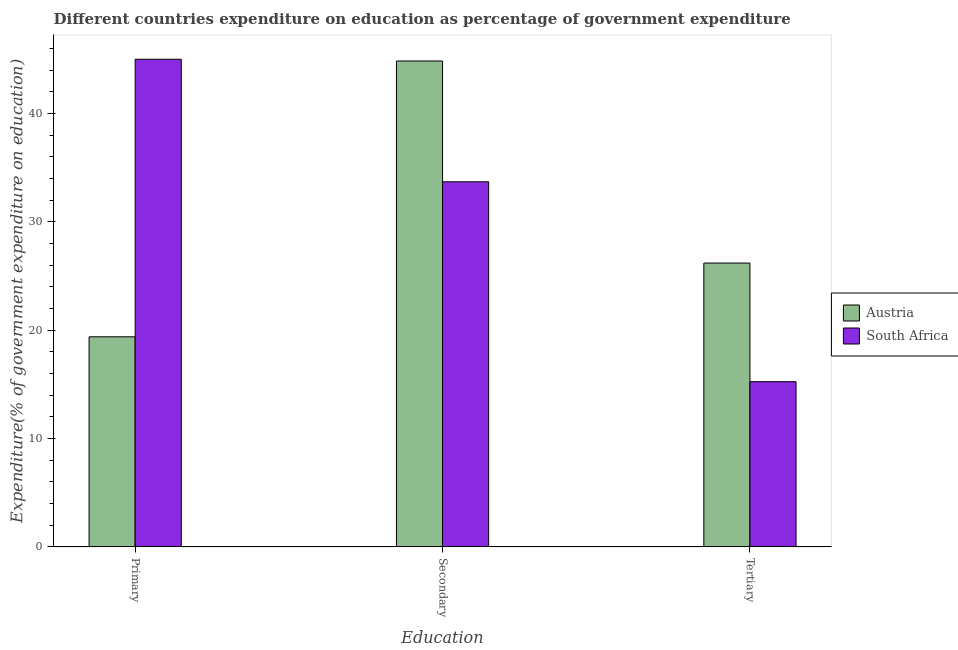How many different coloured bars are there?
Offer a very short reply. 2. How many bars are there on the 3rd tick from the right?
Your answer should be compact. 2. What is the label of the 3rd group of bars from the left?
Your response must be concise. Tertiary. What is the expenditure on primary education in Austria?
Your answer should be compact. 19.38. Across all countries, what is the maximum expenditure on primary education?
Your answer should be very brief. 44.99. Across all countries, what is the minimum expenditure on secondary education?
Make the answer very short. 33.69. In which country was the expenditure on primary education maximum?
Offer a very short reply. South Africa. In which country was the expenditure on primary education minimum?
Make the answer very short. Austria. What is the total expenditure on secondary education in the graph?
Give a very brief answer. 78.52. What is the difference between the expenditure on tertiary education in South Africa and that in Austria?
Provide a succinct answer. -10.94. What is the difference between the expenditure on tertiary education in South Africa and the expenditure on primary education in Austria?
Ensure brevity in your answer.  -4.14. What is the average expenditure on secondary education per country?
Provide a succinct answer. 39.26. What is the difference between the expenditure on tertiary education and expenditure on primary education in South Africa?
Offer a very short reply. -29.75. In how many countries, is the expenditure on primary education greater than 22 %?
Keep it short and to the point. 1. What is the ratio of the expenditure on secondary education in South Africa to that in Austria?
Your answer should be compact. 0.75. What is the difference between the highest and the second highest expenditure on tertiary education?
Provide a short and direct response. 10.94. What is the difference between the highest and the lowest expenditure on secondary education?
Keep it short and to the point. 11.15. In how many countries, is the expenditure on secondary education greater than the average expenditure on secondary education taken over all countries?
Offer a terse response. 1. What does the 2nd bar from the left in Secondary represents?
Offer a terse response. South Africa. What does the 1st bar from the right in Primary represents?
Provide a short and direct response. South Africa. How many bars are there?
Your answer should be compact. 6. Are all the bars in the graph horizontal?
Provide a short and direct response. No. How many countries are there in the graph?
Offer a terse response. 2. Are the values on the major ticks of Y-axis written in scientific E-notation?
Offer a terse response. No. Does the graph contain any zero values?
Keep it short and to the point. No. Does the graph contain grids?
Your answer should be very brief. No. Where does the legend appear in the graph?
Offer a terse response. Center right. How are the legend labels stacked?
Offer a terse response. Vertical. What is the title of the graph?
Your answer should be very brief. Different countries expenditure on education as percentage of government expenditure. What is the label or title of the X-axis?
Offer a terse response. Education. What is the label or title of the Y-axis?
Make the answer very short. Expenditure(% of government expenditure on education). What is the Expenditure(% of government expenditure on education) of Austria in Primary?
Provide a succinct answer. 19.38. What is the Expenditure(% of government expenditure on education) of South Africa in Primary?
Give a very brief answer. 44.99. What is the Expenditure(% of government expenditure on education) in Austria in Secondary?
Offer a very short reply. 44.83. What is the Expenditure(% of government expenditure on education) in South Africa in Secondary?
Provide a succinct answer. 33.69. What is the Expenditure(% of government expenditure on education) of Austria in Tertiary?
Offer a very short reply. 26.19. What is the Expenditure(% of government expenditure on education) of South Africa in Tertiary?
Your answer should be compact. 15.24. Across all Education, what is the maximum Expenditure(% of government expenditure on education) of Austria?
Offer a very short reply. 44.83. Across all Education, what is the maximum Expenditure(% of government expenditure on education) in South Africa?
Your answer should be very brief. 44.99. Across all Education, what is the minimum Expenditure(% of government expenditure on education) in Austria?
Make the answer very short. 19.38. Across all Education, what is the minimum Expenditure(% of government expenditure on education) in South Africa?
Ensure brevity in your answer.  15.24. What is the total Expenditure(% of government expenditure on education) of Austria in the graph?
Keep it short and to the point. 90.4. What is the total Expenditure(% of government expenditure on education) of South Africa in the graph?
Make the answer very short. 93.92. What is the difference between the Expenditure(% of government expenditure on education) of Austria in Primary and that in Secondary?
Offer a terse response. -25.45. What is the difference between the Expenditure(% of government expenditure on education) in South Africa in Primary and that in Secondary?
Make the answer very short. 11.31. What is the difference between the Expenditure(% of government expenditure on education) of Austria in Primary and that in Tertiary?
Make the answer very short. -6.8. What is the difference between the Expenditure(% of government expenditure on education) in South Africa in Primary and that in Tertiary?
Give a very brief answer. 29.75. What is the difference between the Expenditure(% of government expenditure on education) of Austria in Secondary and that in Tertiary?
Your answer should be compact. 18.65. What is the difference between the Expenditure(% of government expenditure on education) in South Africa in Secondary and that in Tertiary?
Provide a succinct answer. 18.44. What is the difference between the Expenditure(% of government expenditure on education) of Austria in Primary and the Expenditure(% of government expenditure on education) of South Africa in Secondary?
Offer a terse response. -14.3. What is the difference between the Expenditure(% of government expenditure on education) of Austria in Primary and the Expenditure(% of government expenditure on education) of South Africa in Tertiary?
Make the answer very short. 4.14. What is the difference between the Expenditure(% of government expenditure on education) of Austria in Secondary and the Expenditure(% of government expenditure on education) of South Africa in Tertiary?
Offer a very short reply. 29.59. What is the average Expenditure(% of government expenditure on education) in Austria per Education?
Give a very brief answer. 30.13. What is the average Expenditure(% of government expenditure on education) of South Africa per Education?
Your answer should be very brief. 31.31. What is the difference between the Expenditure(% of government expenditure on education) in Austria and Expenditure(% of government expenditure on education) in South Africa in Primary?
Offer a very short reply. -25.61. What is the difference between the Expenditure(% of government expenditure on education) of Austria and Expenditure(% of government expenditure on education) of South Africa in Secondary?
Keep it short and to the point. 11.15. What is the difference between the Expenditure(% of government expenditure on education) of Austria and Expenditure(% of government expenditure on education) of South Africa in Tertiary?
Keep it short and to the point. 10.94. What is the ratio of the Expenditure(% of government expenditure on education) of Austria in Primary to that in Secondary?
Offer a very short reply. 0.43. What is the ratio of the Expenditure(% of government expenditure on education) of South Africa in Primary to that in Secondary?
Offer a terse response. 1.34. What is the ratio of the Expenditure(% of government expenditure on education) in Austria in Primary to that in Tertiary?
Your answer should be very brief. 0.74. What is the ratio of the Expenditure(% of government expenditure on education) in South Africa in Primary to that in Tertiary?
Your answer should be compact. 2.95. What is the ratio of the Expenditure(% of government expenditure on education) in Austria in Secondary to that in Tertiary?
Your answer should be very brief. 1.71. What is the ratio of the Expenditure(% of government expenditure on education) in South Africa in Secondary to that in Tertiary?
Offer a very short reply. 2.21. What is the difference between the highest and the second highest Expenditure(% of government expenditure on education) in Austria?
Make the answer very short. 18.65. What is the difference between the highest and the second highest Expenditure(% of government expenditure on education) of South Africa?
Offer a terse response. 11.31. What is the difference between the highest and the lowest Expenditure(% of government expenditure on education) in Austria?
Your answer should be very brief. 25.45. What is the difference between the highest and the lowest Expenditure(% of government expenditure on education) in South Africa?
Provide a succinct answer. 29.75. 